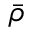Convert formula to latex. <formula><loc_0><loc_0><loc_500><loc_500>\bar { \rho }</formula> 